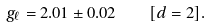<formula> <loc_0><loc_0><loc_500><loc_500>g _ { \ell } = 2 . 0 1 \pm 0 . 0 2 \quad [ d = 2 ] .</formula> 